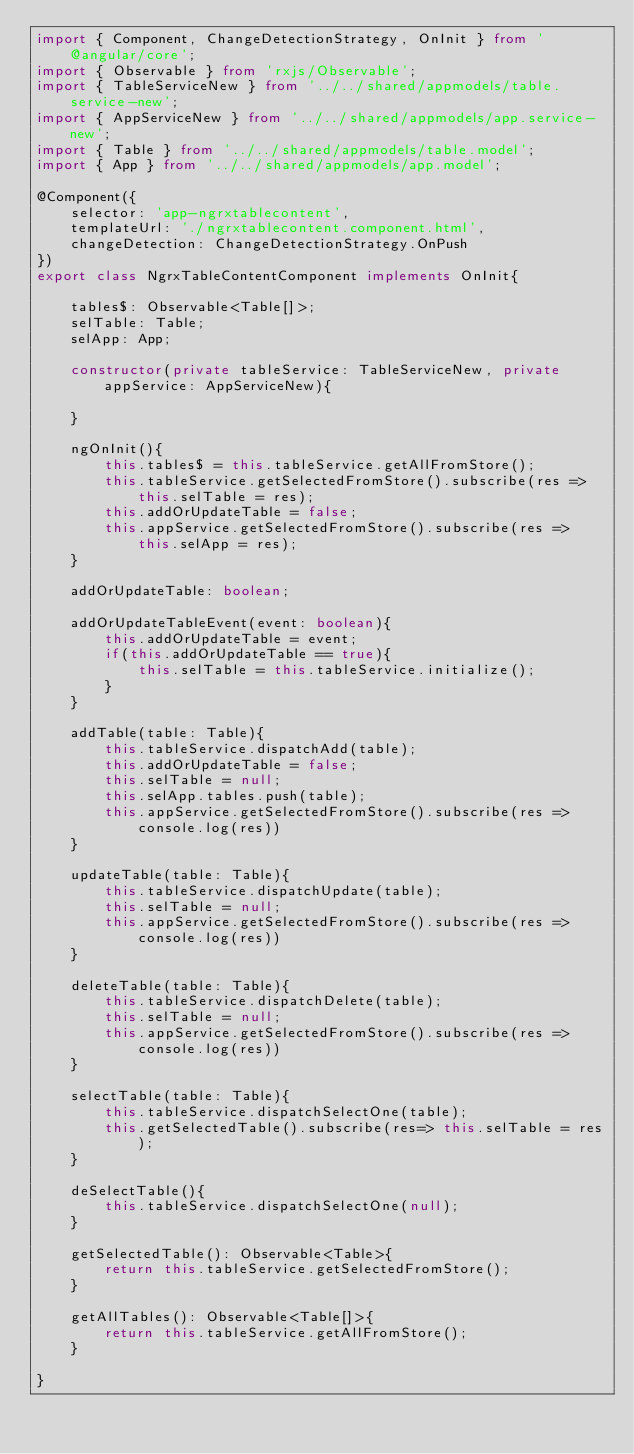<code> <loc_0><loc_0><loc_500><loc_500><_TypeScript_>import { Component, ChangeDetectionStrategy, OnInit } from '@angular/core';
import { Observable } from 'rxjs/Observable';
import { TableServiceNew } from '../../shared/appmodels/table.service-new';
import { AppServiceNew } from '../../shared/appmodels/app.service-new';
import { Table } from '../../shared/appmodels/table.model';
import { App } from '../../shared/appmodels/app.model';

@Component({
    selector: 'app-ngrxtablecontent',
    templateUrl: './ngrxtablecontent.component.html',
    changeDetection: ChangeDetectionStrategy.OnPush
})
export class NgrxTableContentComponent implements OnInit{
    
    tables$: Observable<Table[]>;
    selTable: Table;
    selApp: App;

    constructor(private tableService: TableServiceNew, private appService: AppServiceNew){

    }

    ngOnInit(){
        this.tables$ = this.tableService.getAllFromStore();
        this.tableService.getSelectedFromStore().subscribe(res => this.selTable = res);
        this.addOrUpdateTable = false;
        this.appService.getSelectedFromStore().subscribe(res => this.selApp = res);
    }

    addOrUpdateTable: boolean;

    addOrUpdateTableEvent(event: boolean){
        this.addOrUpdateTable = event;
        if(this.addOrUpdateTable == true){
            this.selTable = this.tableService.initialize();
        }
    }

    addTable(table: Table){
        this.tableService.dispatchAdd(table);
        this.addOrUpdateTable = false;
        this.selTable = null;
        this.selApp.tables.push(table);
        this.appService.getSelectedFromStore().subscribe(res => console.log(res))
    }

    updateTable(table: Table){
        this.tableService.dispatchUpdate(table);
        this.selTable = null;
        this.appService.getSelectedFromStore().subscribe(res => console.log(res))
    }

    deleteTable(table: Table){
        this.tableService.dispatchDelete(table);
        this.selTable = null;
        this.appService.getSelectedFromStore().subscribe(res => console.log(res))
    }

    selectTable(table: Table){
        this.tableService.dispatchSelectOne(table);
        this.getSelectedTable().subscribe(res=> this.selTable = res);
    }

    deSelectTable(){
        this.tableService.dispatchSelectOne(null);
    }

    getSelectedTable(): Observable<Table>{
        return this.tableService.getSelectedFromStore();
    }

    getAllTables(): Observable<Table[]>{
        return this.tableService.getAllFromStore();
    }

}</code> 